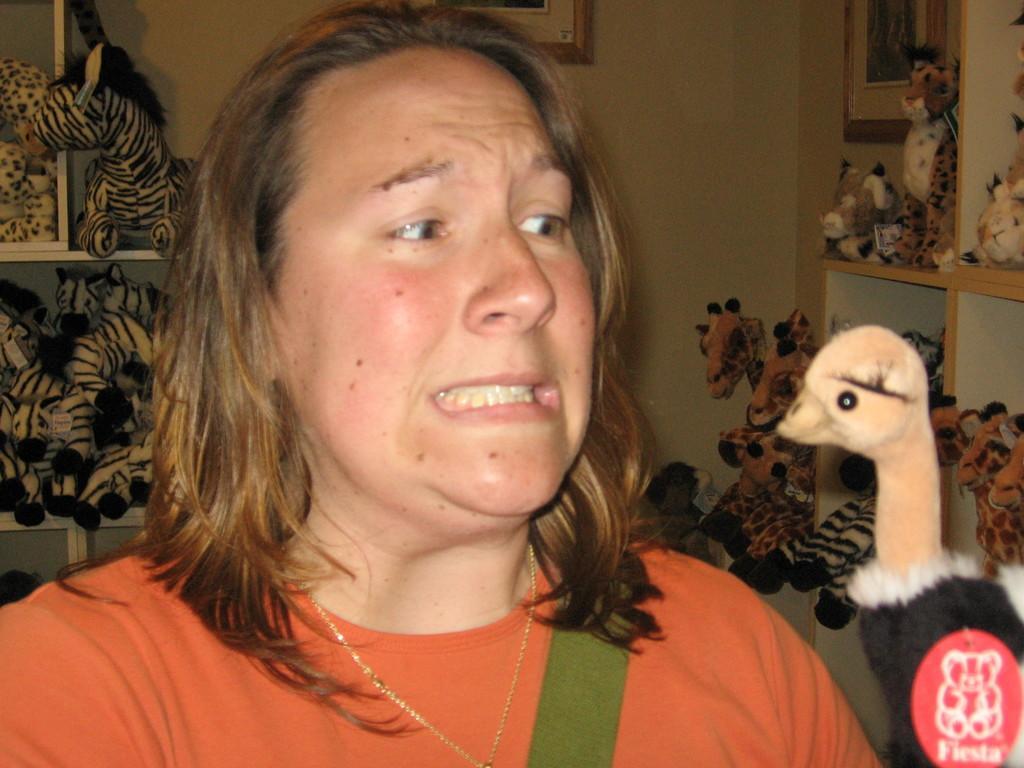In one or two sentences, can you explain what this image depicts? In this image we can see a woman. In the background there are different types of toys arranged in the shelves. 